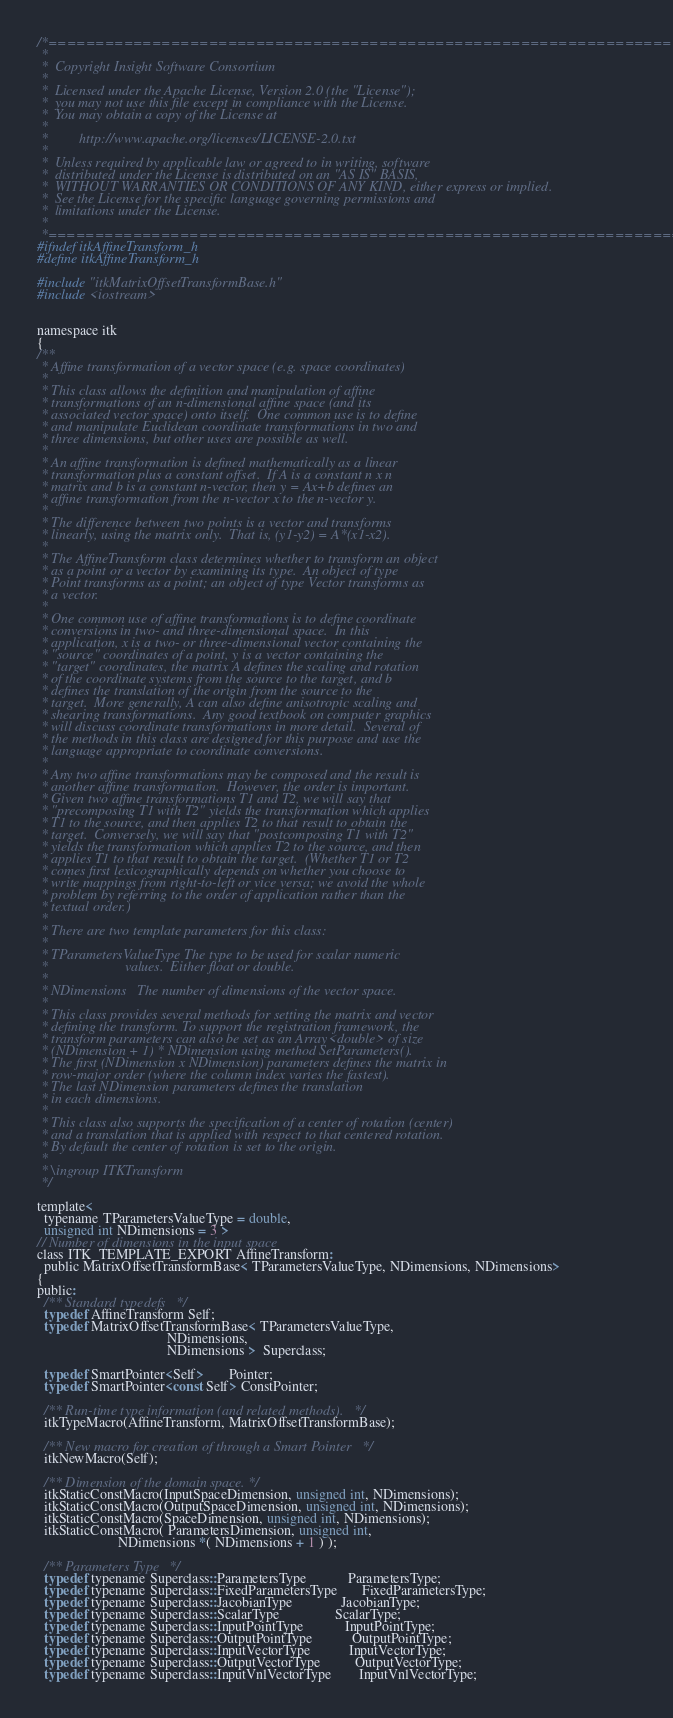Convert code to text. <code><loc_0><loc_0><loc_500><loc_500><_C_>/*=========================================================================
 *
 *  Copyright Insight Software Consortium
 *
 *  Licensed under the Apache License, Version 2.0 (the "License");
 *  you may not use this file except in compliance with the License.
 *  You may obtain a copy of the License at
 *
 *         http://www.apache.org/licenses/LICENSE-2.0.txt
 *
 *  Unless required by applicable law or agreed to in writing, software
 *  distributed under the License is distributed on an "AS IS" BASIS,
 *  WITHOUT WARRANTIES OR CONDITIONS OF ANY KIND, either express or implied.
 *  See the License for the specific language governing permissions and
 *  limitations under the License.
 *
 *=========================================================================*/
#ifndef itkAffineTransform_h
#define itkAffineTransform_h

#include "itkMatrixOffsetTransformBase.h"
#include <iostream>


namespace itk
{
/**
 * Affine transformation of a vector space (e.g. space coordinates)
 *
 * This class allows the definition and manipulation of affine
 * transformations of an n-dimensional affine space (and its
 * associated vector space) onto itself.  One common use is to define
 * and manipulate Euclidean coordinate transformations in two and
 * three dimensions, but other uses are possible as well.
 *
 * An affine transformation is defined mathematically as a linear
 * transformation plus a constant offset.  If A is a constant n x n
 * matrix and b is a constant n-vector, then y = Ax+b defines an
 * affine transformation from the n-vector x to the n-vector y.
 *
 * The difference between two points is a vector and transforms
 * linearly, using the matrix only.  That is, (y1-y2) = A*(x1-x2).
 *
 * The AffineTransform class determines whether to transform an object
 * as a point or a vector by examining its type.  An object of type
 * Point transforms as a point; an object of type Vector transforms as
 * a vector.
 *
 * One common use of affine transformations is to define coordinate
 * conversions in two- and three-dimensional space.  In this
 * application, x is a two- or three-dimensional vector containing the
 * "source" coordinates of a point, y is a vector containing the
 * "target" coordinates, the matrix A defines the scaling and rotation
 * of the coordinate systems from the source to the target, and b
 * defines the translation of the origin from the source to the
 * target.  More generally, A can also define anisotropic scaling and
 * shearing transformations.  Any good textbook on computer graphics
 * will discuss coordinate transformations in more detail.  Several of
 * the methods in this class are designed for this purpose and use the
 * language appropriate to coordinate conversions.
 *
 * Any two affine transformations may be composed and the result is
 * another affine transformation.  However, the order is important.
 * Given two affine transformations T1 and T2, we will say that
 * "precomposing T1 with T2" yields the transformation which applies
 * T1 to the source, and then applies T2 to that result to obtain the
 * target.  Conversely, we will say that "postcomposing T1 with T2"
 * yields the transformation which applies T2 to the source, and then
 * applies T1 to that result to obtain the target.  (Whether T1 or T2
 * comes first lexicographically depends on whether you choose to
 * write mappings from right-to-left or vice versa; we avoid the whole
 * problem by referring to the order of application rather than the
 * textual order.)
 *
 * There are two template parameters for this class:
 *
 * TParametersValueType The type to be used for scalar numeric
 *                      values.  Either float or double.
 *
 * NDimensions   The number of dimensions of the vector space.
 *
 * This class provides several methods for setting the matrix and vector
 * defining the transform. To support the registration framework, the
 * transform parameters can also be set as an Array<double> of size
 * (NDimension + 1) * NDimension using method SetParameters().
 * The first (NDimension x NDimension) parameters defines the matrix in
 * row-major order (where the column index varies the fastest).
 * The last NDimension parameters defines the translation
 * in each dimensions.
 *
 * This class also supports the specification of a center of rotation (center)
 * and a translation that is applied with respect to that centered rotation.
 * By default the center of rotation is set to the origin.
 *
 * \ingroup ITKTransform
 */

template<
  typename TParametersValueType = double,
  unsigned int NDimensions = 3 >
// Number of dimensions in the input space
class ITK_TEMPLATE_EXPORT AffineTransform:
  public MatrixOffsetTransformBase< TParametersValueType, NDimensions, NDimensions>
{
public:
  /** Standard typedefs   */
  typedef AffineTransform Self;
  typedef MatrixOffsetTransformBase< TParametersValueType,
                                     NDimensions,
                                     NDimensions >  Superclass;

  typedef SmartPointer<Self>       Pointer;
  typedef SmartPointer<const Self> ConstPointer;

  /** Run-time type information (and related methods).   */
  itkTypeMacro(AffineTransform, MatrixOffsetTransformBase);

  /** New macro for creation of through a Smart Pointer   */
  itkNewMacro(Self);

  /** Dimension of the domain space. */
  itkStaticConstMacro(InputSpaceDimension, unsigned int, NDimensions);
  itkStaticConstMacro(OutputSpaceDimension, unsigned int, NDimensions);
  itkStaticConstMacro(SpaceDimension, unsigned int, NDimensions);
  itkStaticConstMacro( ParametersDimension, unsigned int,
                       NDimensions *( NDimensions + 1 ) );

  /** Parameters Type   */
  typedef typename Superclass::ParametersType            ParametersType;
  typedef typename Superclass::FixedParametersType       FixedParametersType;
  typedef typename Superclass::JacobianType              JacobianType;
  typedef typename Superclass::ScalarType                ScalarType;
  typedef typename Superclass::InputPointType            InputPointType;
  typedef typename Superclass::OutputPointType           OutputPointType;
  typedef typename Superclass::InputVectorType           InputVectorType;
  typedef typename Superclass::OutputVectorType          OutputVectorType;
  typedef typename Superclass::InputVnlVectorType        InputVnlVectorType;</code> 